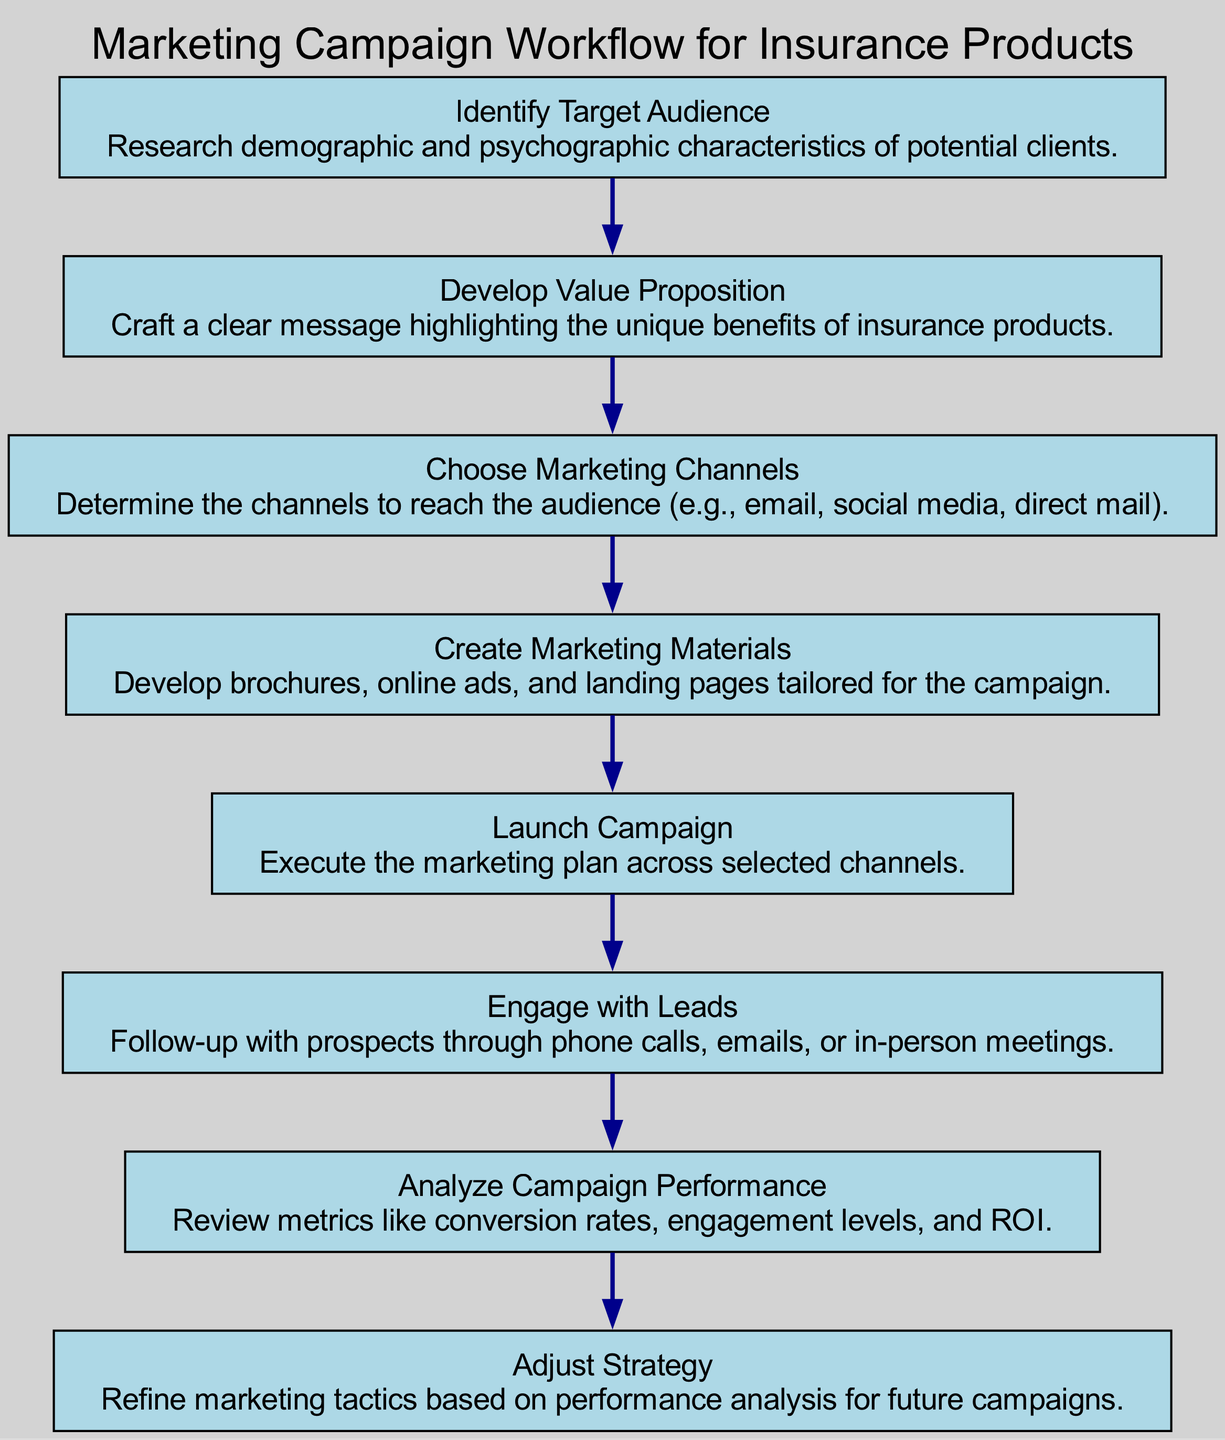What is the first step in the marketing campaign workflow? The first step is "Identify Target Audience," which is the first node listed in the diagram.
Answer: Identify Target Audience How many nodes are present in the diagram? There are eight nodes representing different steps in the workflow from the start to the end of the process.
Answer: 8 What follows the "Choose Marketing Channels" step? The "Create Marketing Materials" step directly follows the "Choose Marketing Channels" in the workflow, indicating the next action after selecting the channels.
Answer: Create Marketing Materials Which step involves communication with prospects? "Engage with Leads" is the step that specifically involves following up and communicating with prospects based on the marketing efforts.
Answer: Engage with Leads What is the last action taken in the workflow? The last action is "Adjust Strategy," which is the final node in the workflow, indicating a review and adjustment based on performance analysis.
Answer: Adjust Strategy How many times is "Analyze Campaign Performance" mentioned? "Analyze Campaign Performance" is mentioned once as a distinct step in the flowchart, indicating its unique role in the process.
Answer: 1 Link the "Launch Campaign" step to its preceding step. "Launch Campaign" is preceded by "Create Marketing Materials," meaning that the materials must be developed before the actual campaign is launched.
Answer: Create Marketing Materials What step directly leads to performance evaluation? "Analyze Campaign Performance" directly leads to evaluating the effectiveness of the campaign, following the launch and engagement processes.
Answer: Analyze Campaign Performance What element is crucial before creating marketing materials? "Choose Marketing Channels" is crucial as it determines the platforms for distributing the marketing materials, which informs their creation.
Answer: Choose Marketing Channels 